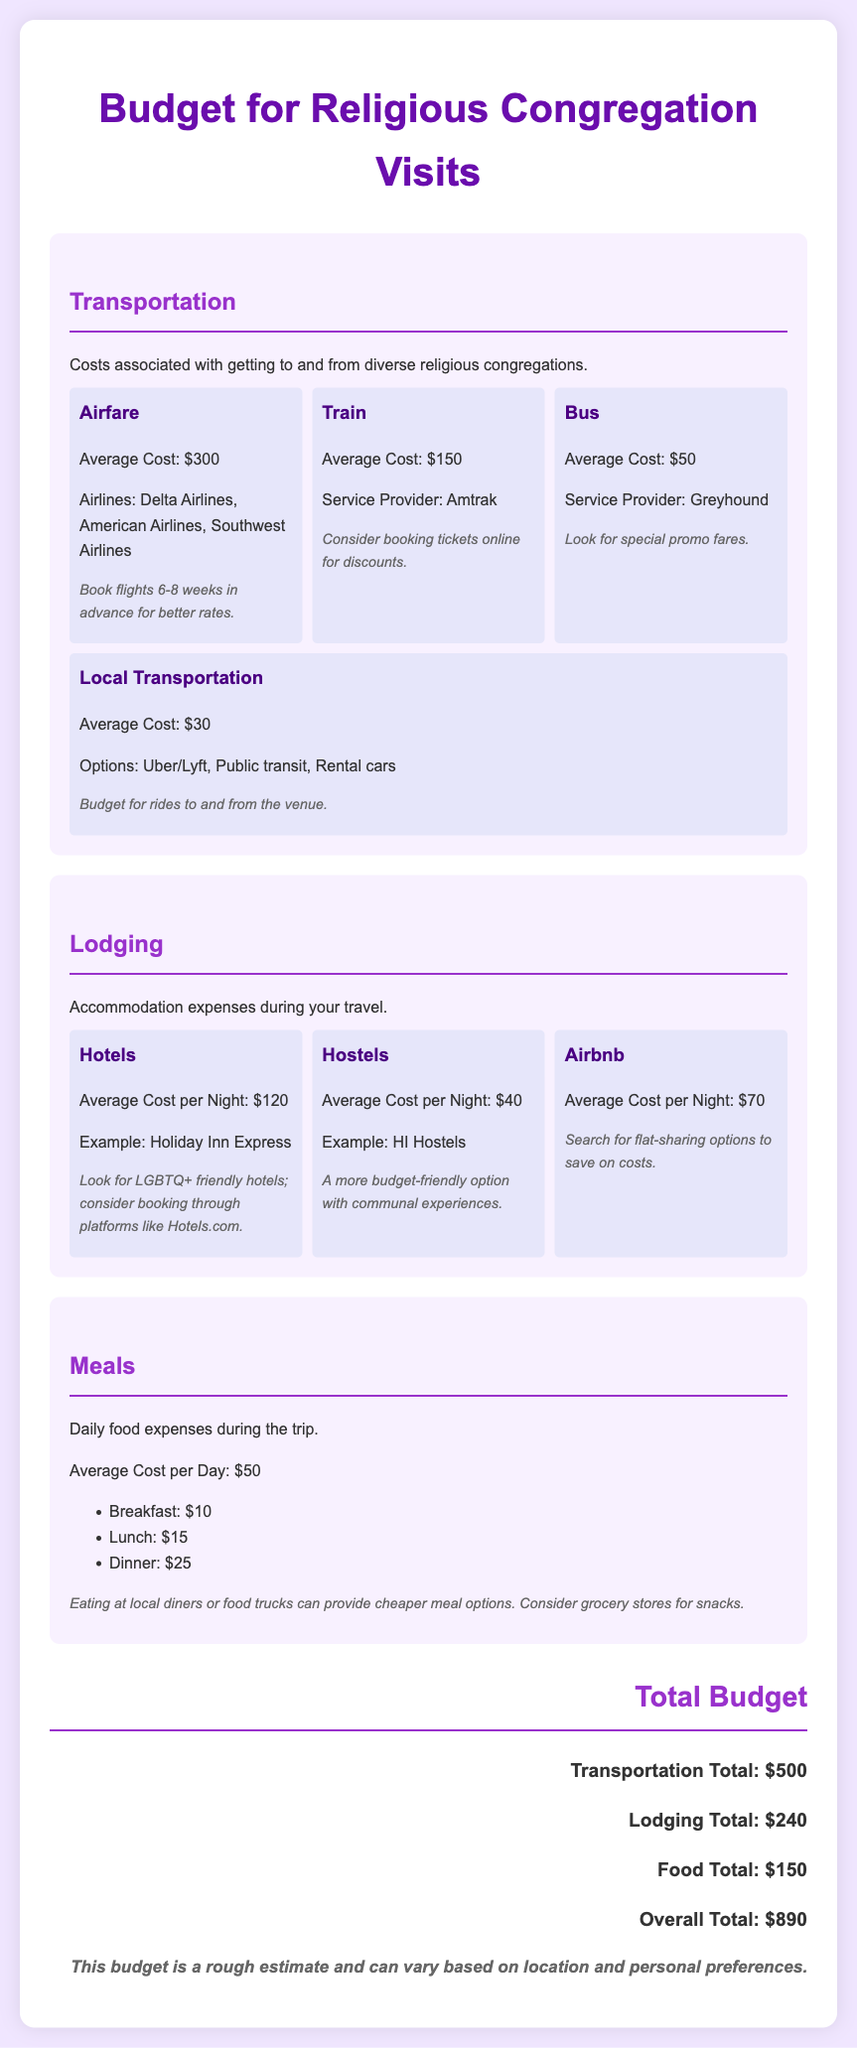What is the average cost of airfare? The document states that the average cost of airfare is $300.
Answer: $300 How much should you budget for local transportation? The document indicates that the average cost for local transportation is $30.
Answer: $30 What is the average cost of staying in a hostel per night? According to the document, the average cost per night for hostels is $40.
Answer: $40 What is the total budget for transportation, lodging, and meals? The total budget combines costs from all sections, totaling $890.
Answer: $890 What is the average meal cost per day? The document provides that the average cost for meals per day is $50.
Answer: $50 What is the lodging total? The total lodging cost, as specified in the document, is $240.
Answer: $240 How much can you save by choosing bus transportation over airfare? By choosing bus transportation at $50 instead of airfare at $300, you save $250.
Answer: $250 Which transportation option is the cheapest? The document lists the bus as the cheapest transportation option at $50.
Answer: $50 